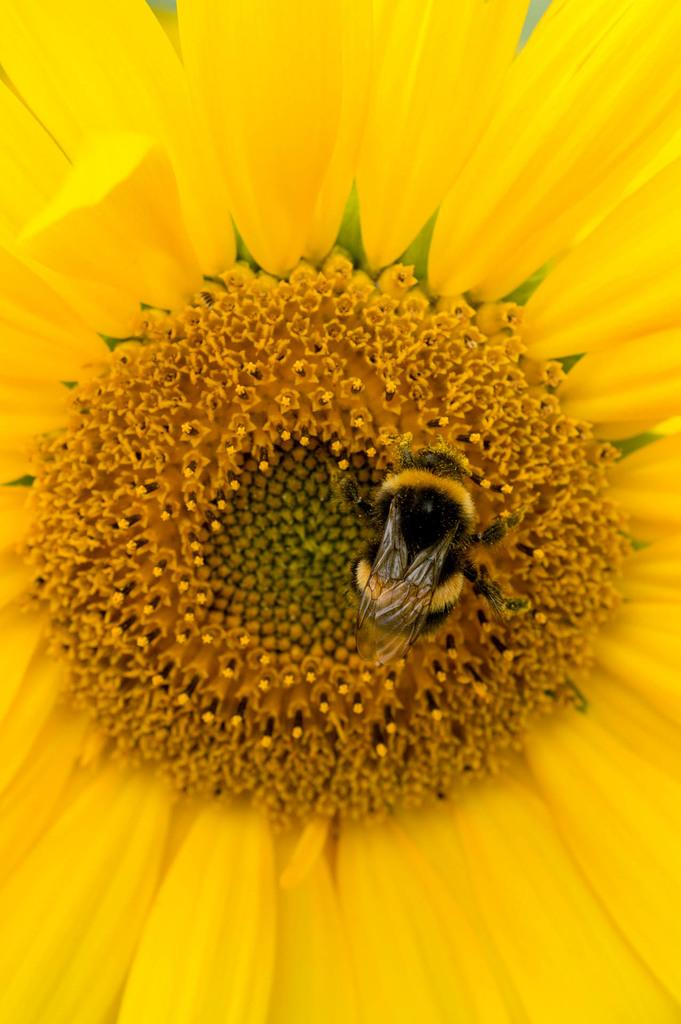What is the main subject of the image? There is a flower in the image. How is the flower depicted in the image? The flower is partially cut off or "truncated" in the image. Are there any other living organisms present in the image? Yes, there is an insect on the flower. What type of boat can be seen in the image? There is no boat present in the image; it features a flower with an insect on it. What substance is the flower made of in the image? The flower is a natural, organic object made of plant material, not a substance. 